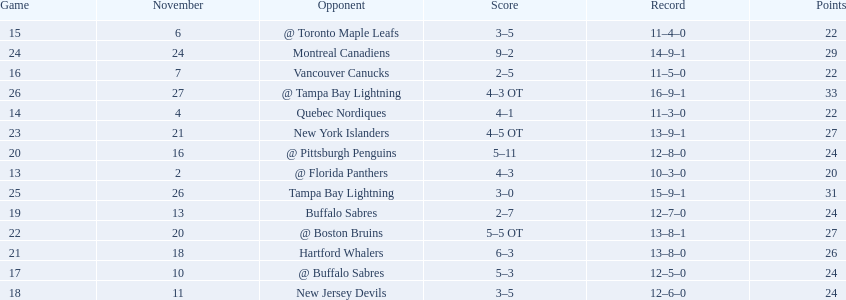What are the teams in the atlantic division? Quebec Nordiques, Vancouver Canucks, New Jersey Devils, Buffalo Sabres, Hartford Whalers, New York Islanders, Montreal Canadiens, Tampa Bay Lightning. Which of those scored fewer points than the philadelphia flyers? Tampa Bay Lightning. 